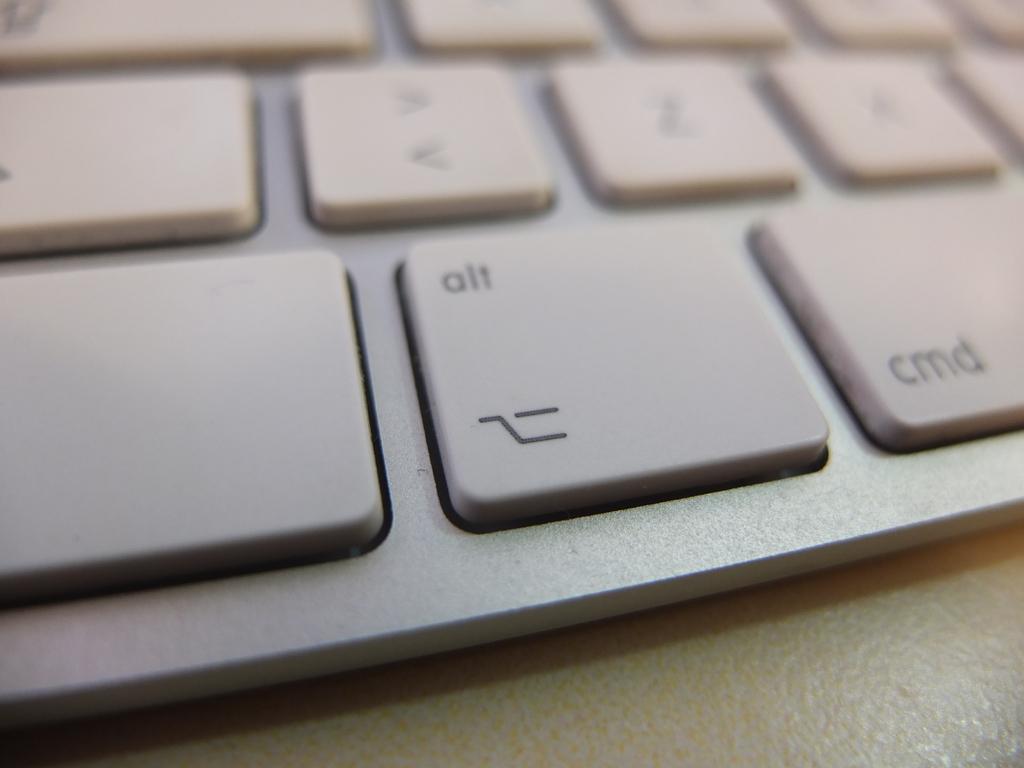In one or two sentences, can you explain what this image depicts? In this image we can see a keyboard with text and symbols. 